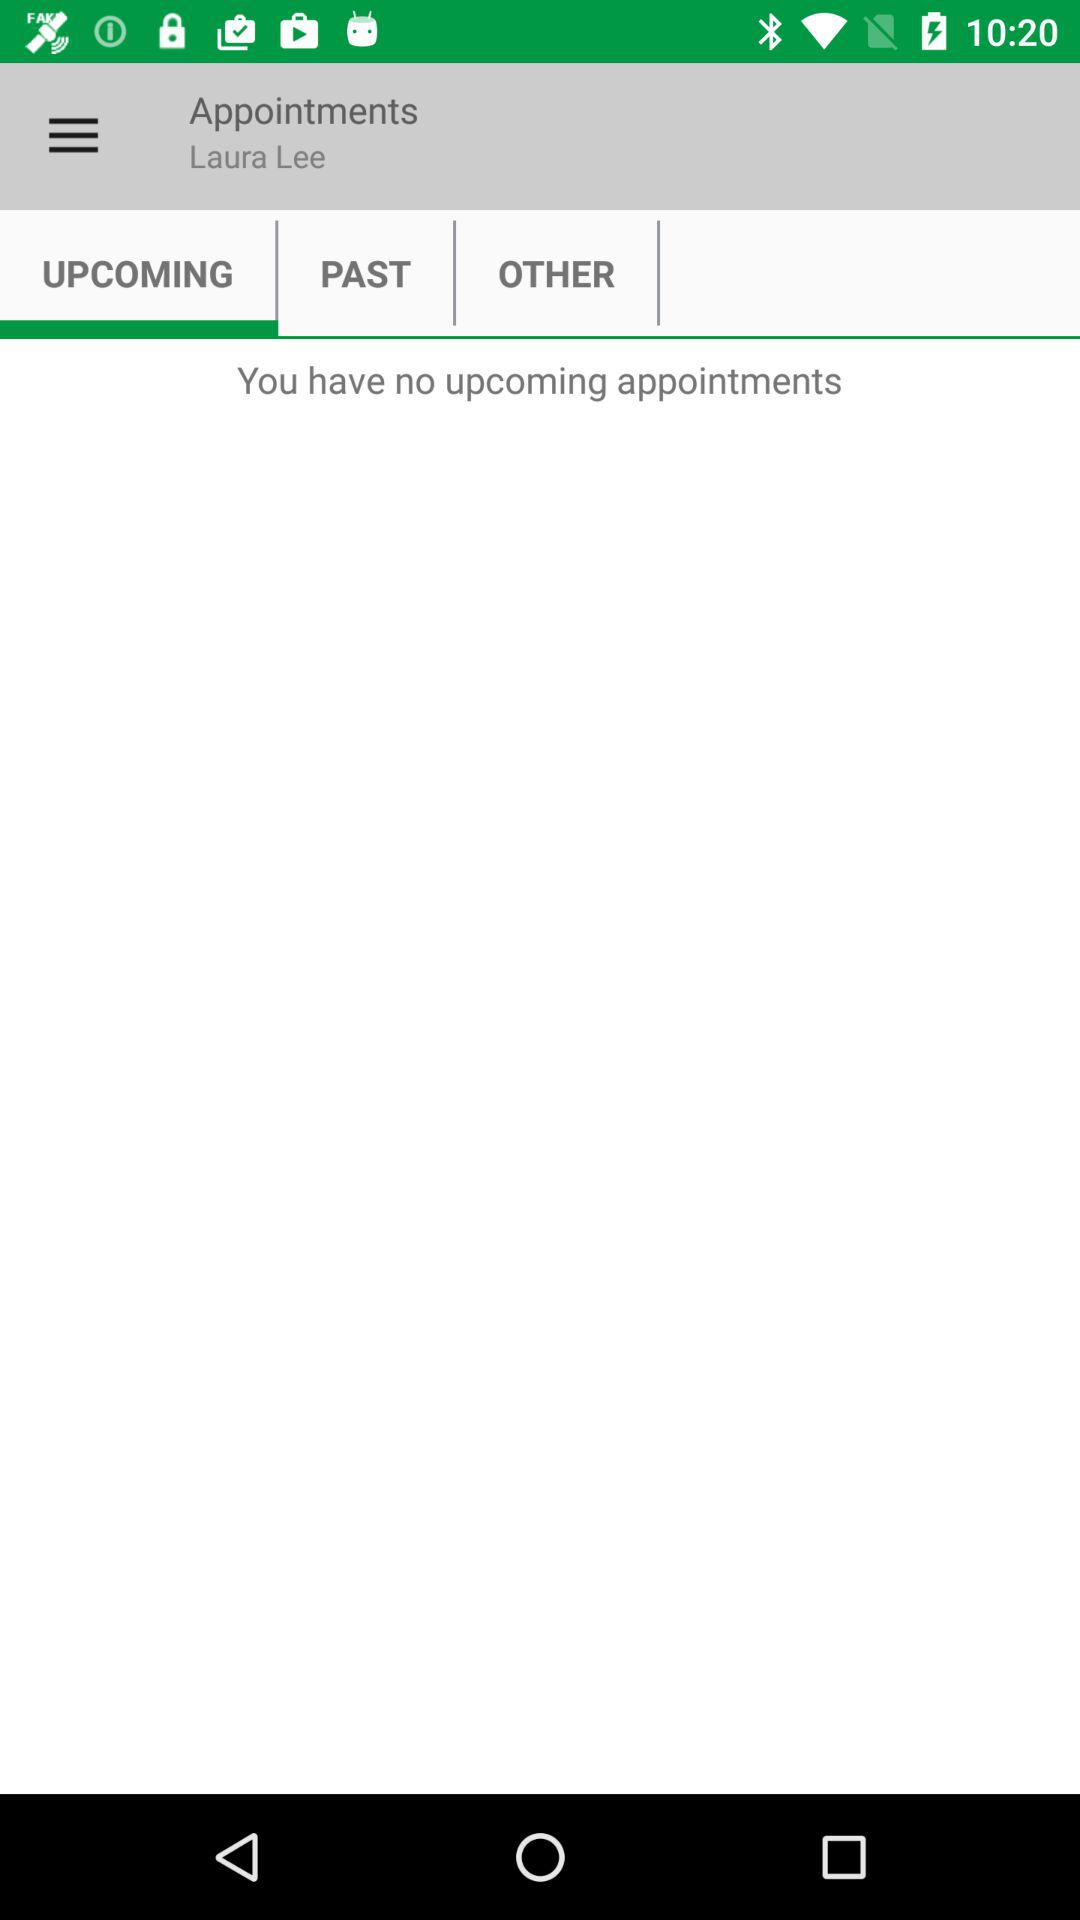What is the given user name? The given user name is Laura Lee. 